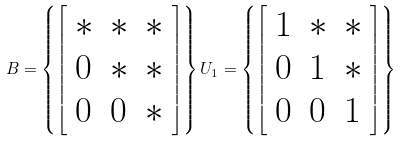Convert formula to latex. <formula><loc_0><loc_0><loc_500><loc_500>B = \left \{ { \left [ \begin{array} { l l l } { * } & { * } & { * } \\ { 0 } & { * } & { * } \\ { 0 } & { 0 } & { * } \end{array} \right ] } \right \} U _ { 1 } = \left \{ { \left [ \begin{array} { l l l } { 1 } & { * } & { * } \\ { 0 } & { 1 } & { * } \\ { 0 } & { 0 } & { 1 } \end{array} \right ] } \right \}</formula> 